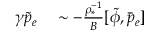<formula> <loc_0><loc_0><loc_500><loc_500>\begin{array} { r l } { \gamma \tilde { p } _ { e } } & \sim - \frac { \rho _ { * } ^ { - 1 } } { B } [ \tilde { \phi } , \bar { p } _ { e } ] } \end{array}</formula> 